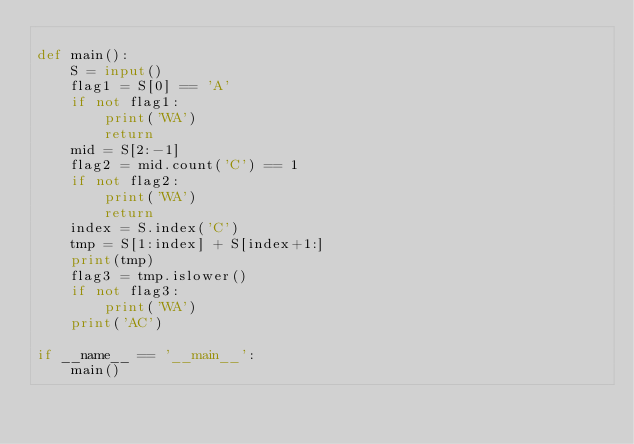<code> <loc_0><loc_0><loc_500><loc_500><_Python_>
def main():
    S = input()
    flag1 = S[0] == 'A'
    if not flag1:
        print('WA')
        return 
    mid = S[2:-1]
    flag2 = mid.count('C') == 1
    if not flag2:
        print('WA')
        return
    index = S.index('C')
    tmp = S[1:index] + S[index+1:]
    print(tmp)
    flag3 = tmp.islower()
    if not flag3:
        print('WA')
    print('AC')

if __name__ == '__main__':
    main()</code> 